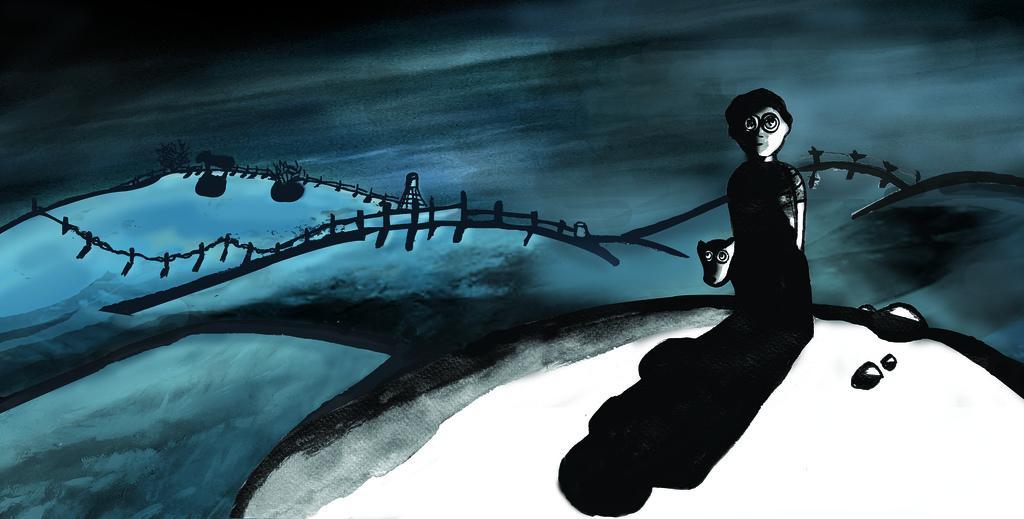How would you summarize this image in a sentence or two? This is an animated picture, in this image we can see a person, animals, plants, fence, water and some other objects. 